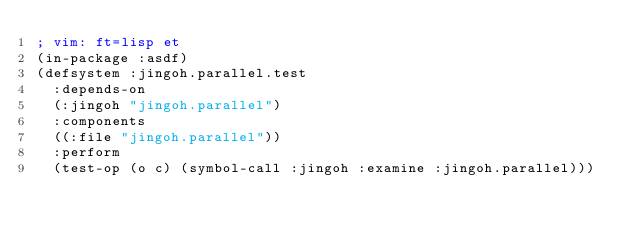Convert code to text. <code><loc_0><loc_0><loc_500><loc_500><_Lisp_>; vim: ft=lisp et
(in-package :asdf)
(defsystem :jingoh.parallel.test
  :depends-on
  (:jingoh "jingoh.parallel")
  :components
  ((:file "jingoh.parallel"))
  :perform
  (test-op (o c) (symbol-call :jingoh :examine :jingoh.parallel)))</code> 